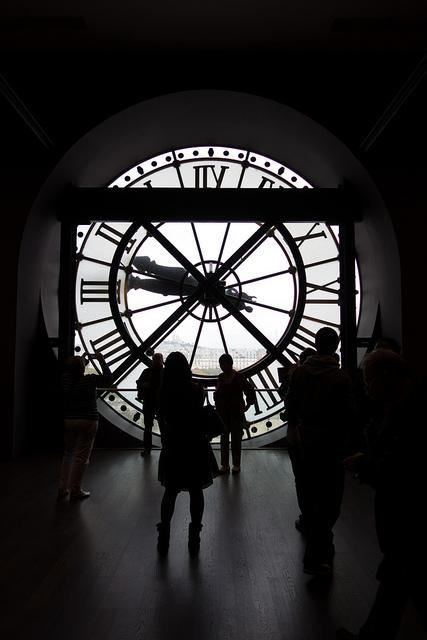What time is depicted in the photo? Please explain your reasoning. 215. The hands depict 2:15 but in reverse since they are inside the clock. 